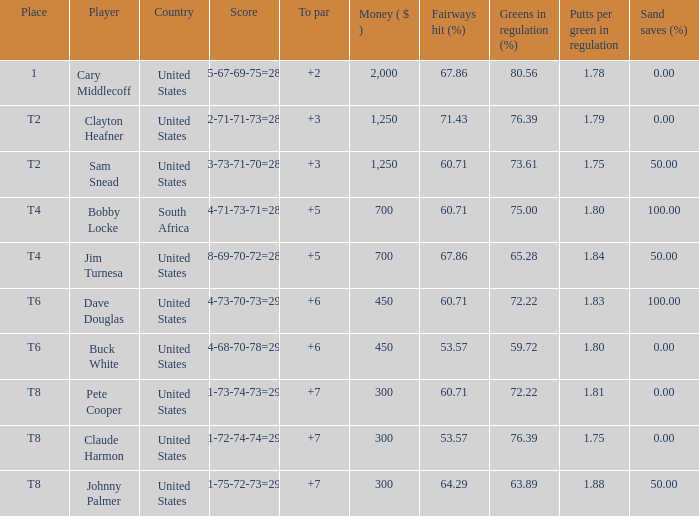What is the Johnny Palmer with a To larger than 6 Money sum? 300.0. 